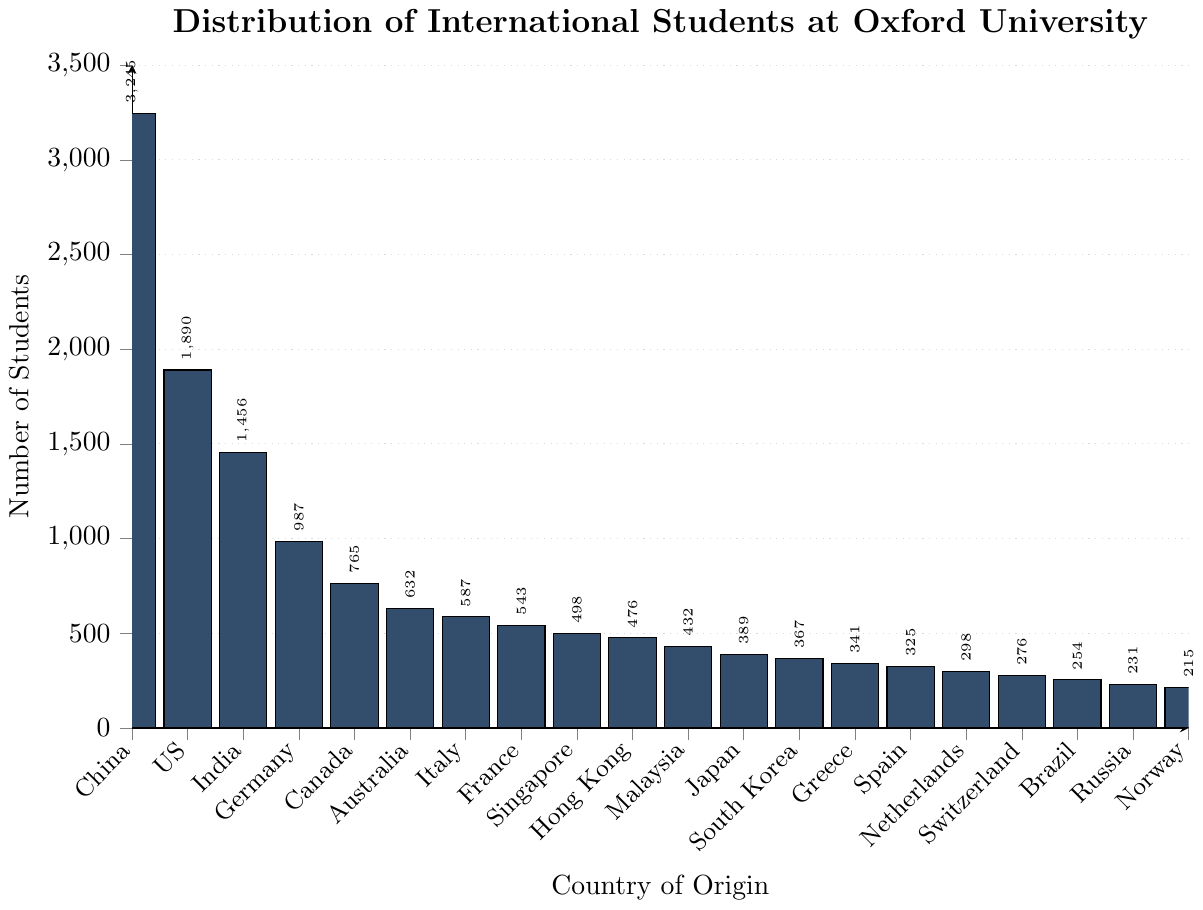Which country has the highest number of international students at Oxford University? By inspecting the height of the bars, the bar representing China is the tallest, indicating it has the highest number of students.
Answer: China Which country has more international students, Canada or Germany? Comparing the heights of the bars for Canada and Germany, the bar for Germany is higher.
Answer: Germany What is the total number of international students from Australia and Canada? Sum the number of students from both countries: 632 (Australia) + 765 (Canada).
Answer: 1397 How many more international students are there from China compared to India? Subtract the number of students from India from the number of students from China: 3245 (China) - 1456 (India).
Answer: 1789 Which two European countries have the closest number of international students? By inspecting the bars for the European countries, Italy (587) and France (543) have the closest numbers, with a difference of 44.
Answer: Italy and France What is the average number of international students for the top three countries? Calculate the average number for China, the United States, and India: (3245 + 1890 + 1456) / 3.
Answer: 2197 Find a country whose number of international students is between that of Japan and Singapore. The number of students for Japan is 389 and for Singapore is 498. The number for Hong Kong, which is between these two values, is 476.
Answer: Hong Kong How many times bigger is the number of international students from China compared to Norway? Divide the number of students from China by the number from Norway: 3245 / 215.
Answer: 15 (approximately) Which country has the fewest international students at Oxford University, and what is the number? By inspecting the shortest bar, Norway has the fewest international students with 215 students.
Answer: Norway If you combine the international students from South Korea and Greece, would their total surpass the number from Germany? Sum the students from South Korea and Greece: 367 + 341 = 708. Compare this value with Germany's 987.
Answer: No 